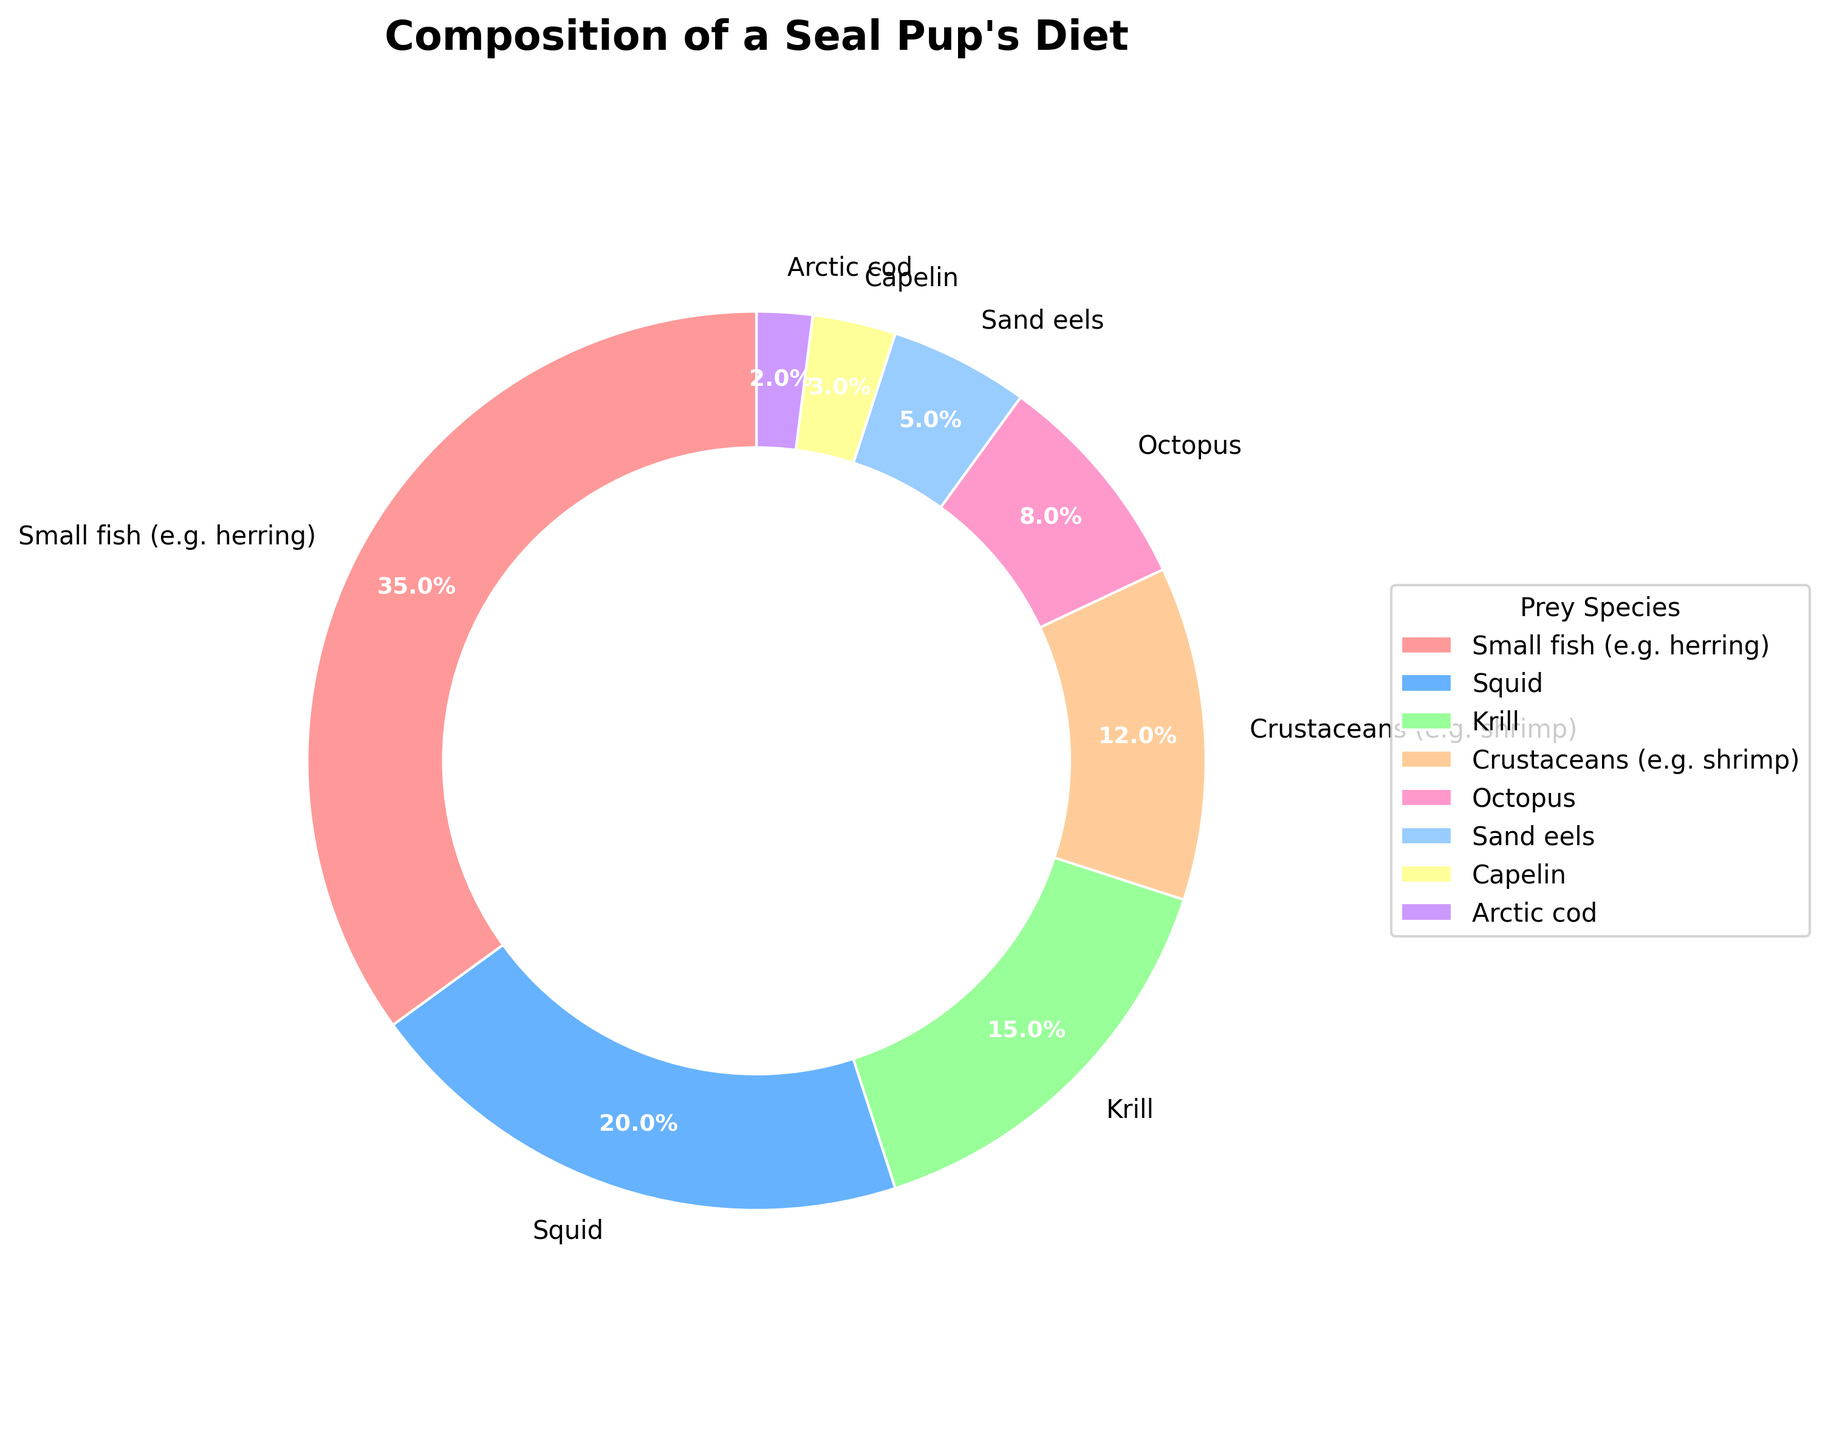Which prey species makes up the largest portion of the seal pup's diet? We look at the largest segment of the pie chart to identify which species has the highest percentage. "Small fish (e.g. herring)" occupies the largest segment with 35%.
Answer: Small fish (e.g. herring) How many prey species make up less than 10% of the seal pup's diet? We identify all segments with less than 10% and count them: "Octopus" (8%), "Sand eels" (5%), "Capelin" (3%), and "Arctic cod" (2%). There are 4 species.
Answer: 4 What is the combined percentage of krill and crustaceans in the seal pup's diet? Sum the percentages for "Krill" (15%) and "Crustaceans" (12%). 15% + 12% = 27%.
Answer: 27% Is the proportion of sand eels greater or smaller than that of squid? Compare the percentages of "Sand eels" (5%) and "Squid" (20%). The proportion of sand eels is smaller.
Answer: Smaller What prey species appears between "Krill" and "Octopus" on the pie chart? We visually locate the segments for "Krill" and "Octopus" and find "Crustaceans (e.g. shrimp)" in between them.
Answer: Crustaceans (e.g. shrimp) Which species' segment has the second smallest percentage? Examine the percentages and find the second smallest: "Arctic cod" is 2%, and second smallest is "Capelin" at 3%.
Answer: Capelin How much more prevalent is the most common prey species compared to the least common one? Subtract the percentage of the least common prey ("Arctic cod" at 2%) from the most common prey ("Small fish (e.g. herring)" at 35%). 35% - 2% = 33%.
Answer: 33% What is the average percentage of "Squid", "Krill", and "Octopus" in the diet? Calculate the average by summing the percentages (20% + 15% + 8% = 43%) and then dividing by 3. 43% / 3 ≈ 14.33%.
Answer: 14.33% Which color represents the "Sand eels" segment on the pie chart? Identify the color used for "Sand eels" by visually inspecting its segment in the chart. The color is yellow.
Answer: Yellow Are there more species contributing more than 10% or less than 10% to the seal pup's diet? Count species above and below 10%: Above 10% (Small fish, Squid, Krill, Crustaceans), Below 10% (Octopus, Sand eels, Capelin, Arctic cod). There are 4 species in each category, thus equal.
Answer: Equal 